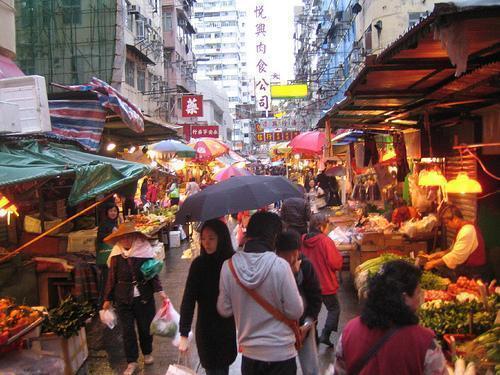What is the occupation of the man in the red vest?
Make your selection from the four choices given to correctly answer the question.
Options: Fashion model, produce vendor, circus acrobat, restaurant chef. Produce vendor. 